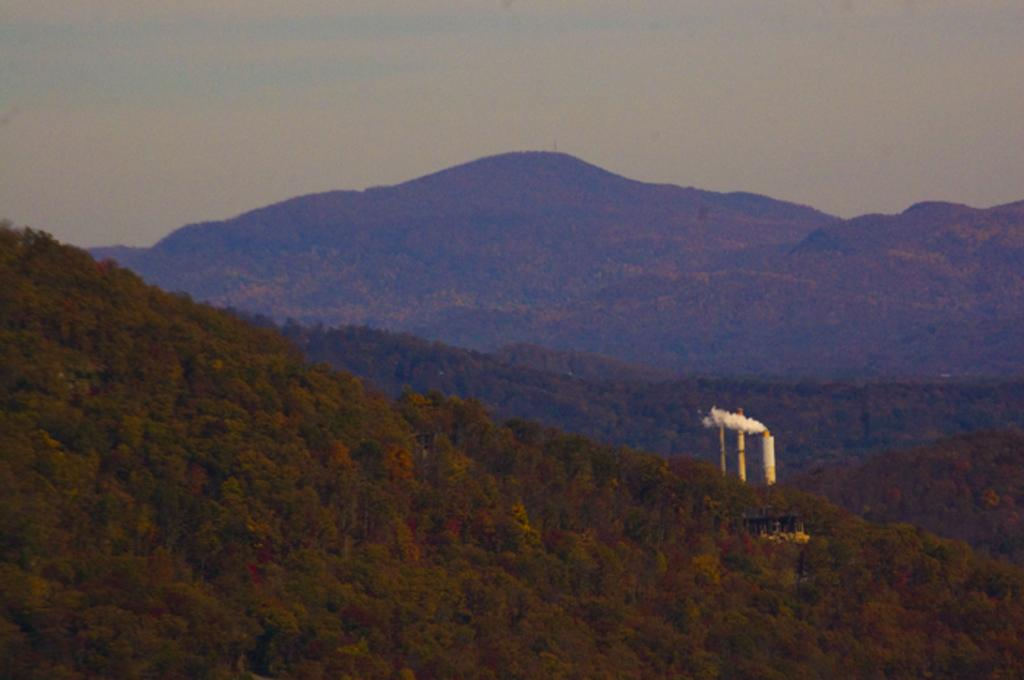What type of structure is the main subject of the image? There is a factory in the image. What is happening with the factory's exhaust? Smoke is visible coming from the factory's exhaust. What can be seen in the background of the image? There are trees on mountains in the background of the image. What is visible at the top of the image? The sky is visible at the top of the image, and clouds are present in the sky. What type of flag is visible on the factory's roof? There is no flag visible on the factory's roof in the image. Can you tell me the total cost of the items purchased from the factory, as shown on the receipt? There is no receipt present in the image, and the cost of items cannot be determined. 